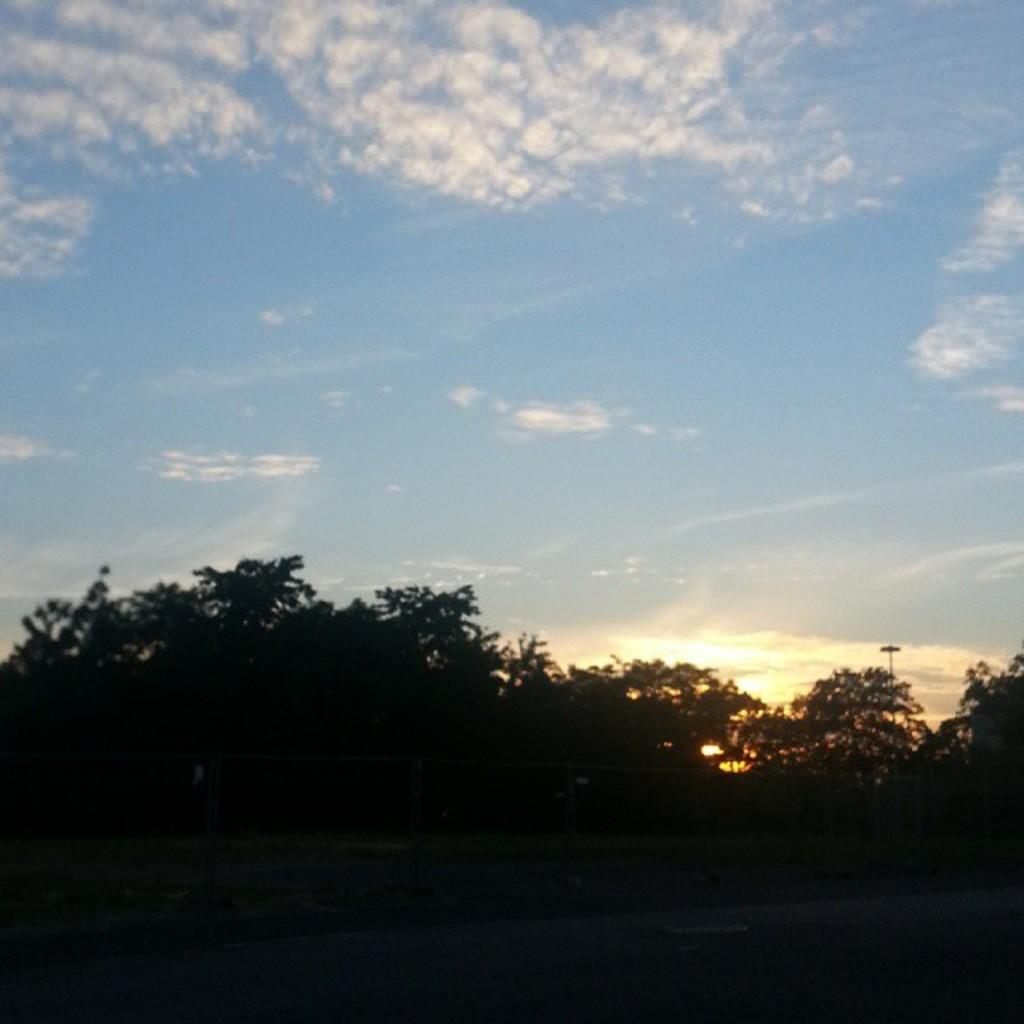What type of vegetation can be seen in the image? There are trees in the image. What is visible in the background of the image? There is a sky visible in the image. Can you describe the sky in the image? The sky contains clouds. Where is the servant standing in the image? There is no servant present in the image. What type of boat can be seen sailing in the image? There is no boat present in the image. 